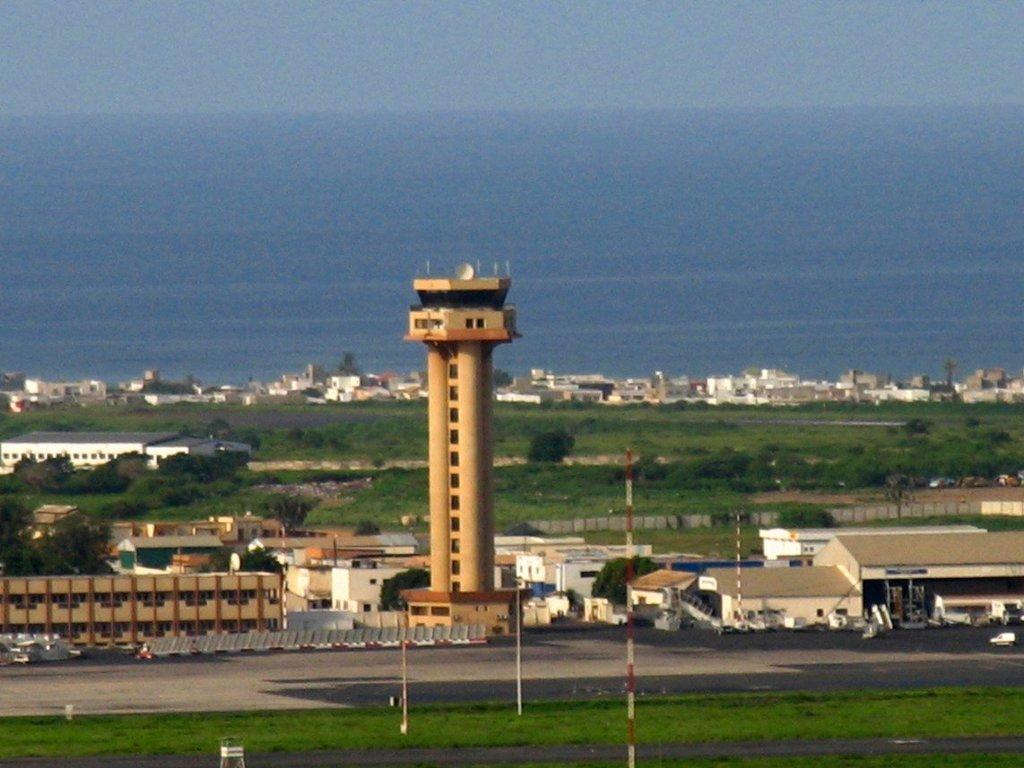Could you give a brief overview of what you see in this image? In this image there is grassland, roads, buildings, tower and the sea. 